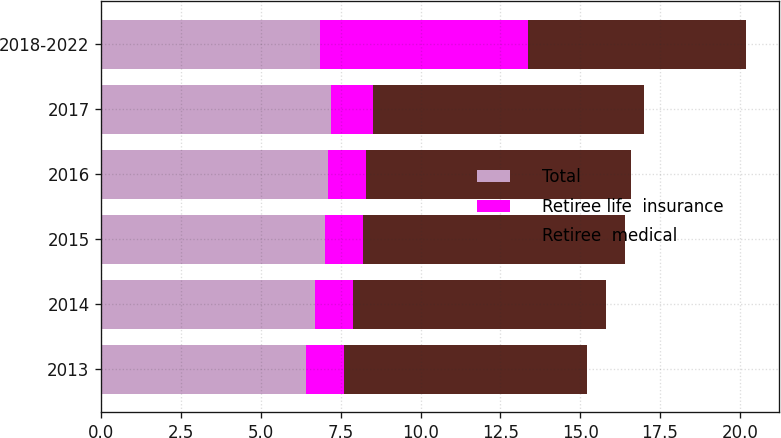<chart> <loc_0><loc_0><loc_500><loc_500><stacked_bar_chart><ecel><fcel>2013<fcel>2014<fcel>2015<fcel>2016<fcel>2017<fcel>2018-2022<nl><fcel>Total<fcel>6.4<fcel>6.7<fcel>7<fcel>7.1<fcel>7.2<fcel>6.85<nl><fcel>Retiree life  insurance<fcel>1.2<fcel>1.2<fcel>1.2<fcel>1.2<fcel>1.3<fcel>6.5<nl><fcel>Retiree  medical<fcel>7.6<fcel>7.9<fcel>8.2<fcel>8.3<fcel>8.5<fcel>6.85<nl></chart> 